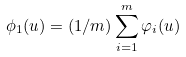<formula> <loc_0><loc_0><loc_500><loc_500>\phi _ { 1 } ( u ) = ( 1 / m ) \sum _ { i = 1 } ^ { m } \varphi _ { i } ( u )</formula> 